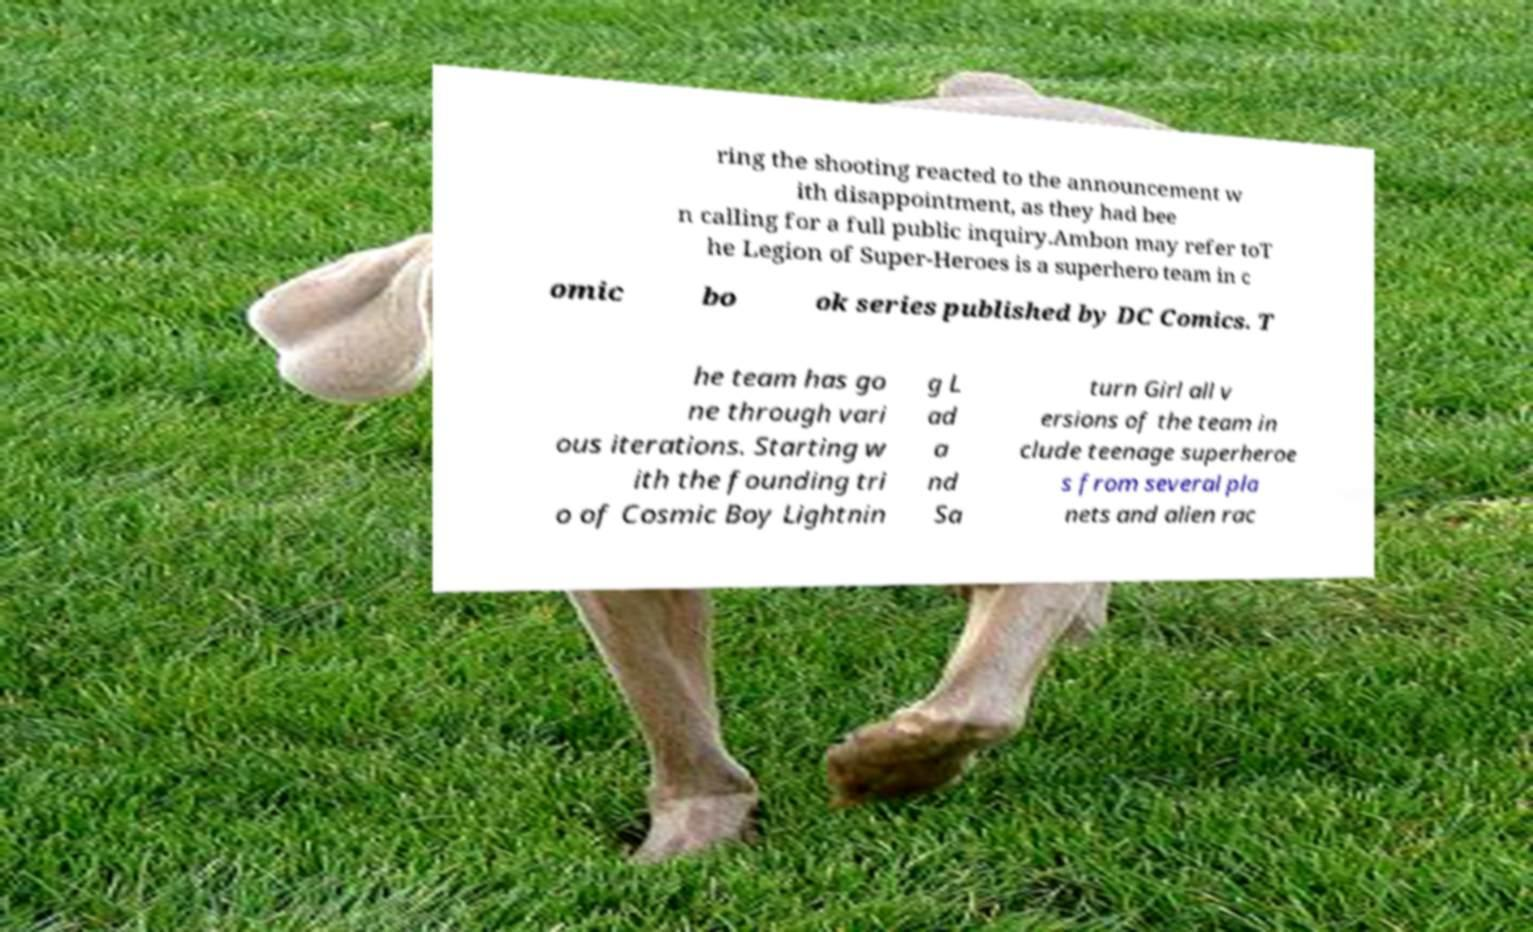I need the written content from this picture converted into text. Can you do that? ring the shooting reacted to the announcement w ith disappointment, as they had bee n calling for a full public inquiry.Ambon may refer toT he Legion of Super-Heroes is a superhero team in c omic bo ok series published by DC Comics. T he team has go ne through vari ous iterations. Starting w ith the founding tri o of Cosmic Boy Lightnin g L ad a nd Sa turn Girl all v ersions of the team in clude teenage superheroe s from several pla nets and alien rac 